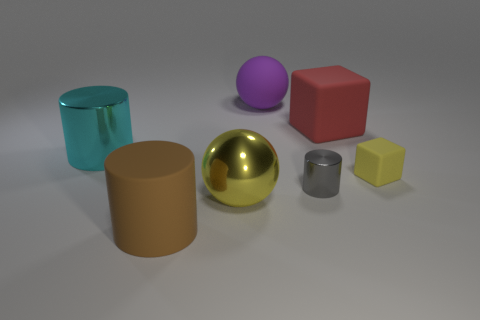Add 3 large purple balls. How many objects exist? 10 Subtract all cylinders. How many objects are left? 4 Subtract 1 yellow spheres. How many objects are left? 6 Subtract all green things. Subtract all big cyan things. How many objects are left? 6 Add 6 rubber blocks. How many rubber blocks are left? 8 Add 7 tiny shiny cylinders. How many tiny shiny cylinders exist? 8 